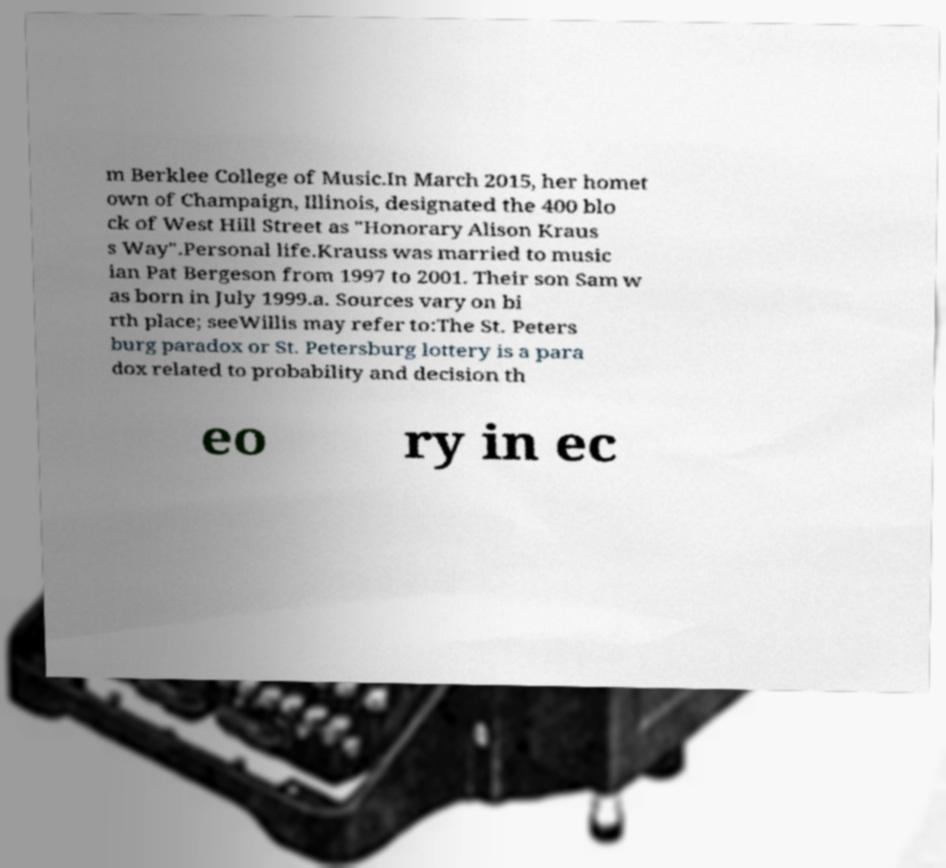Please read and relay the text visible in this image. What does it say? m Berklee College of Music.In March 2015, her homet own of Champaign, Illinois, designated the 400 blo ck of West Hill Street as "Honorary Alison Kraus s Way".Personal life.Krauss was married to music ian Pat Bergeson from 1997 to 2001. Their son Sam w as born in July 1999.a. Sources vary on bi rth place; seeWillis may refer to:The St. Peters burg paradox or St. Petersburg lottery is a para dox related to probability and decision th eo ry in ec 